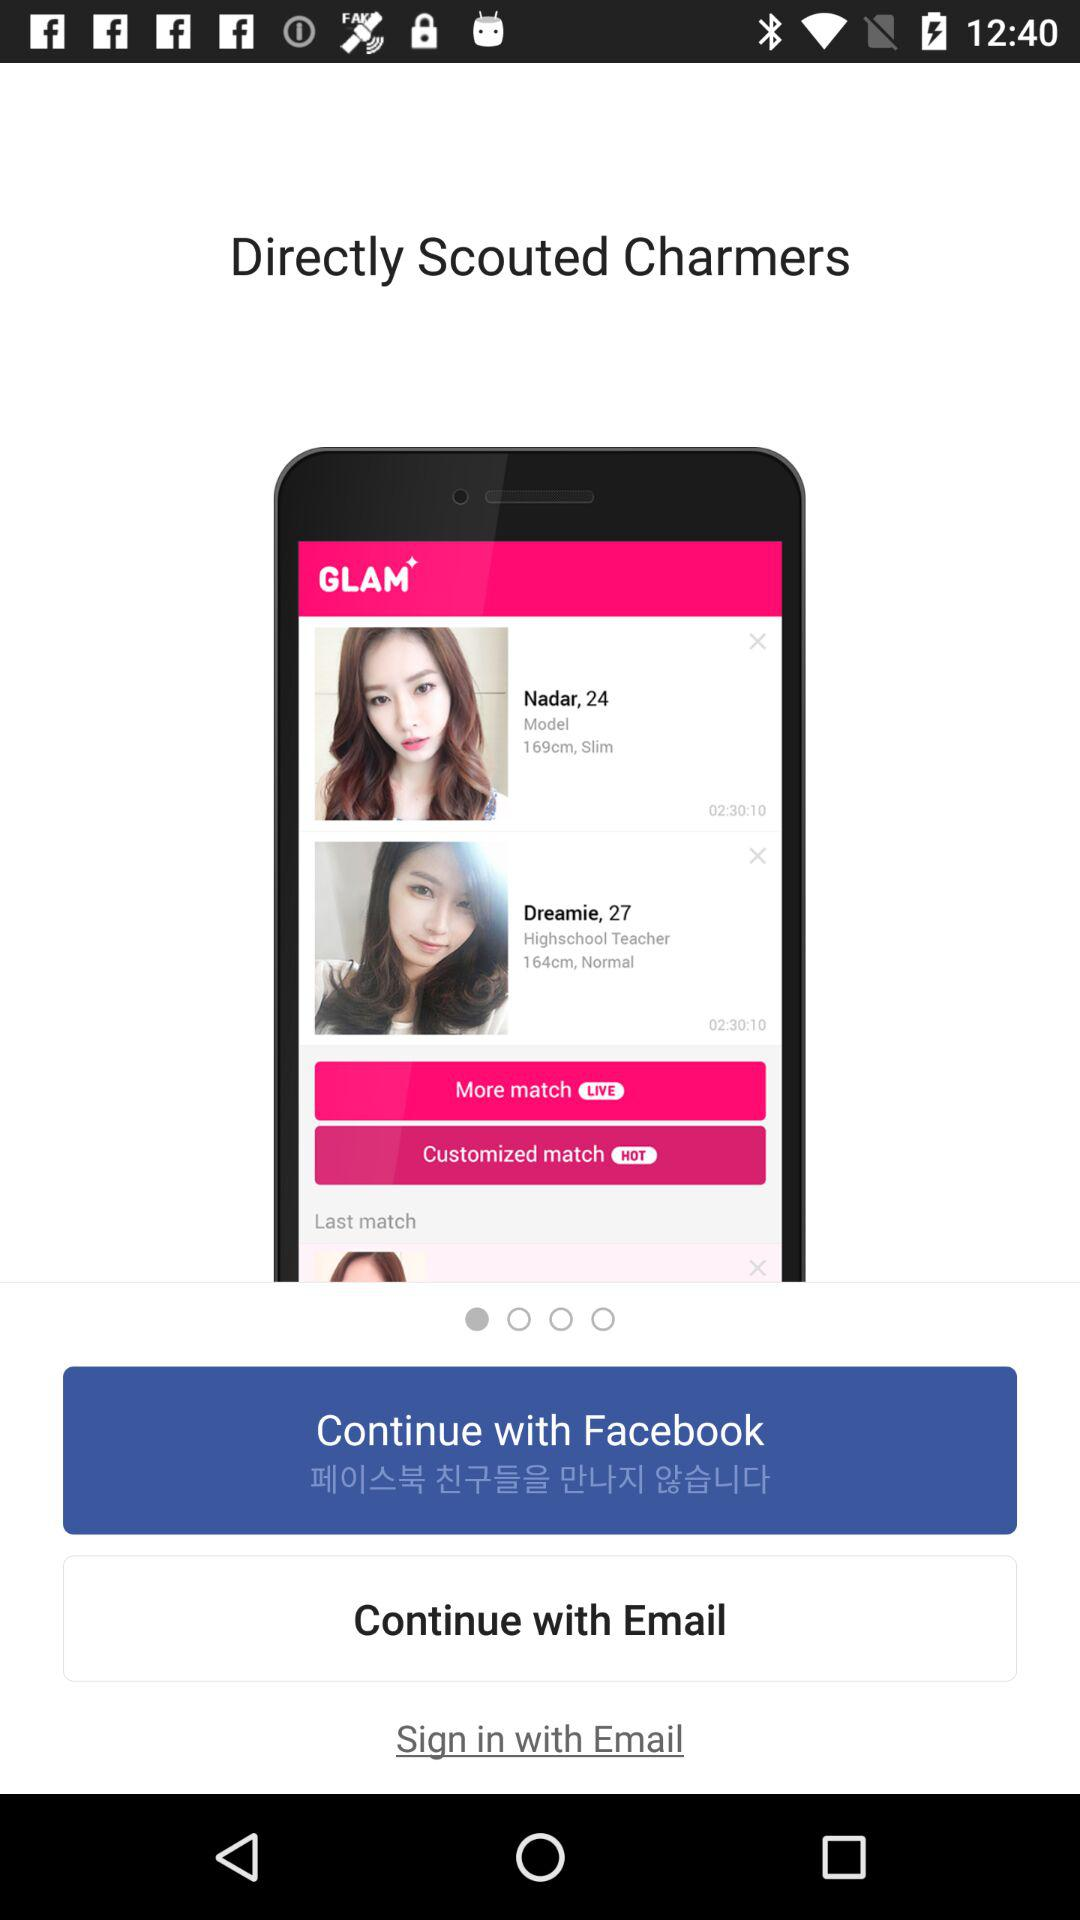What's the age of Nadar? The age of Nadar is 24 years. 